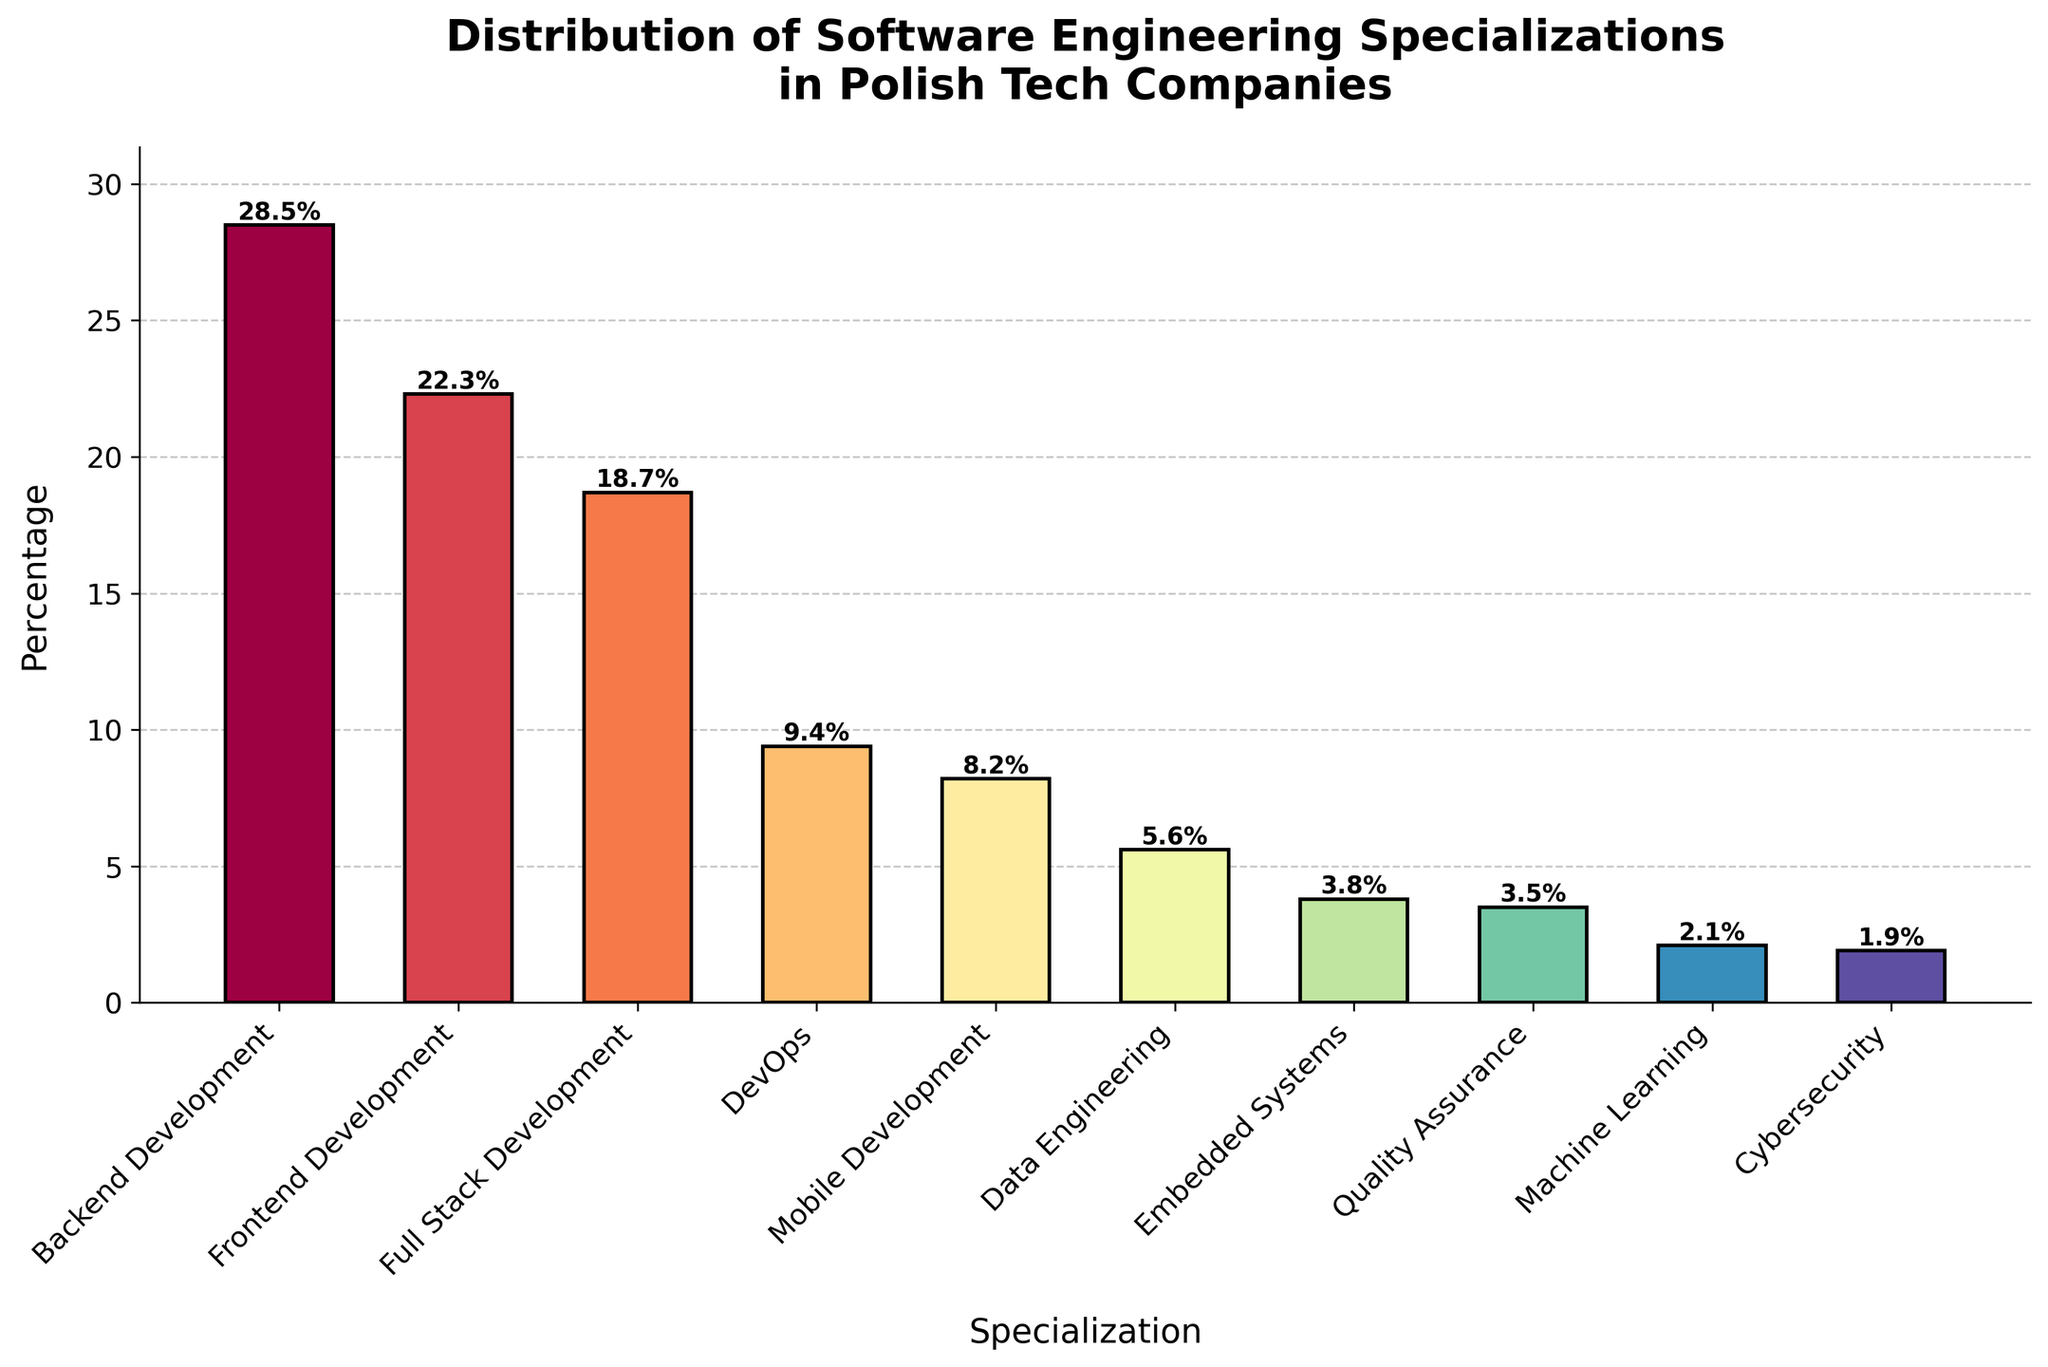What's the most common software engineering specialization in Polish tech companies? The bar chart shows the percentages of various specializations. The tallest bar, representing the highest percentage, indicates the most common specialization, which is Backend Development at 28.5%.
Answer: Backend Development What's the combined percentage of Frontend Development and Full Stack Development specialists? The percentages for Frontend Development and Full Stack Development are 22.3% and 18.7%, respectively. By summing them up, we get 22.3 + 18.7 = 41.0%.
Answer: 41.0% Which specialization ranks fourth in terms of percentage? To find the fourth highest percentage, we inspect the bars descendingly after Backend, Frontend, and Full Stack Development. The next tallest bar represents DevOps at 9.4%.
Answer: DevOps What is the percentage difference between Backend Development and Machine Learning specialization? The percentage for Backend Development is 28.5%, and for Machine Learning, it is 2.1%. The difference is calculated as 28.5 - 2.1 = 26.4%.
Answer: 26.4% Are there more mobile developers or data engineers? Comparing the heights of the bars for Mobile Development (8.2%) and Data Engineering (5.6%), the bar for Mobile Development is taller, indicating more mobile developers.
Answer: Mobile Development What's the average percentage of all listed specializations? To find the average: sum all the percentages and divide by the number of specializations. Sum = 28.5 + 22.3 + 18.7 + 9.4 + 8.2 + 5.6 + 3.8 + 3.5 + 2.1 + 1.9 = 104.0. There are 10 specializations, so the average is 104.0 / 10 = 10.4%.
Answer: 10.4% Which is less common: Quality Assurance or Cybersecurity? Comparing the bars for Quality Assurance (3.5%) and Cybersecurity (1.9%), Cybersecurity has the shorter bar, making it less common.
Answer: Cybersecurity What’s the total percentage of all specializations other than Backend and Frontend Development? Sum the percentages of all specializations except Backend and Frontend: 18.7 + 9.4 + 8.2 + 5.6 + 3.8 + 3.5 + 2.1 + 1.9 = 53.2%.
Answer: 53.2% Which specialization has nearly half the percentage of Frontend Development? Half of Frontend Development (22.3%) is approximately 11.15%. DevOps, with 9.4%, is closest to this value.
Answer: DevOps What percentage of specializations are below 5%? The bars below 5% are Data Engineering (5.6%), Embedded Systems (3.8%), Quality Assurance (3.5%), Machine Learning (2.1%), and Cybersecurity (1.9%). The percentages are 3.8%, 3.5%, 2.1%, and 1.9%, totaling 4 specializations.
Answer: 3.8%, 3.5%, 2.1%, 1.9% 